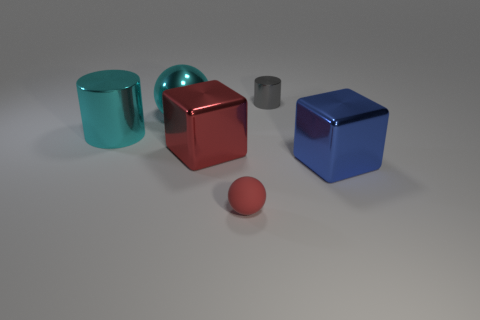Is the number of tiny red balls to the left of the big ball less than the number of blue blocks?
Your answer should be compact. Yes. What material is the thing that is the same size as the red sphere?
Provide a short and direct response. Metal. There is a thing that is both behind the big cyan cylinder and in front of the small shiny cylinder; how big is it?
Offer a very short reply. Large. There is another metal thing that is the same shape as the blue thing; what is its size?
Give a very brief answer. Large. What number of things are either cylinders or large metal things behind the big cylinder?
Give a very brief answer. 3. What shape is the small gray object?
Your response must be concise. Cylinder. The small thing that is on the left side of the cylinder that is to the right of the cyan cylinder is what shape?
Give a very brief answer. Sphere. What material is the object that is the same color as the big cylinder?
Keep it short and to the point. Metal. There is a big sphere that is the same material as the large blue cube; what color is it?
Offer a terse response. Cyan. Is there anything else that is the same size as the red block?
Your answer should be very brief. Yes. 